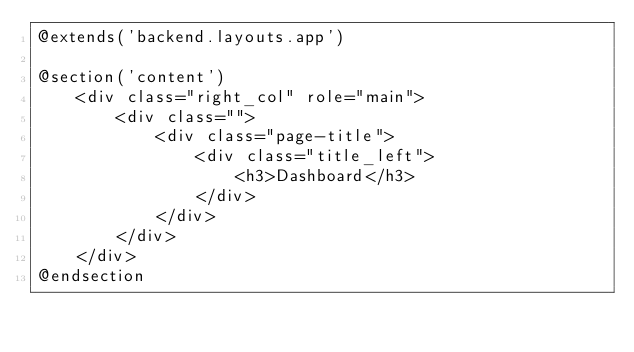Convert code to text. <code><loc_0><loc_0><loc_500><loc_500><_PHP_>@extends('backend.layouts.app')

@section('content')
    <div class="right_col" role="main">
        <div class="">
            <div class="page-title">
                <div class="title_left">
                    <h3>Dashboard</h3>
                </div>
            </div>
        </div>
    </div>
@endsection
</code> 